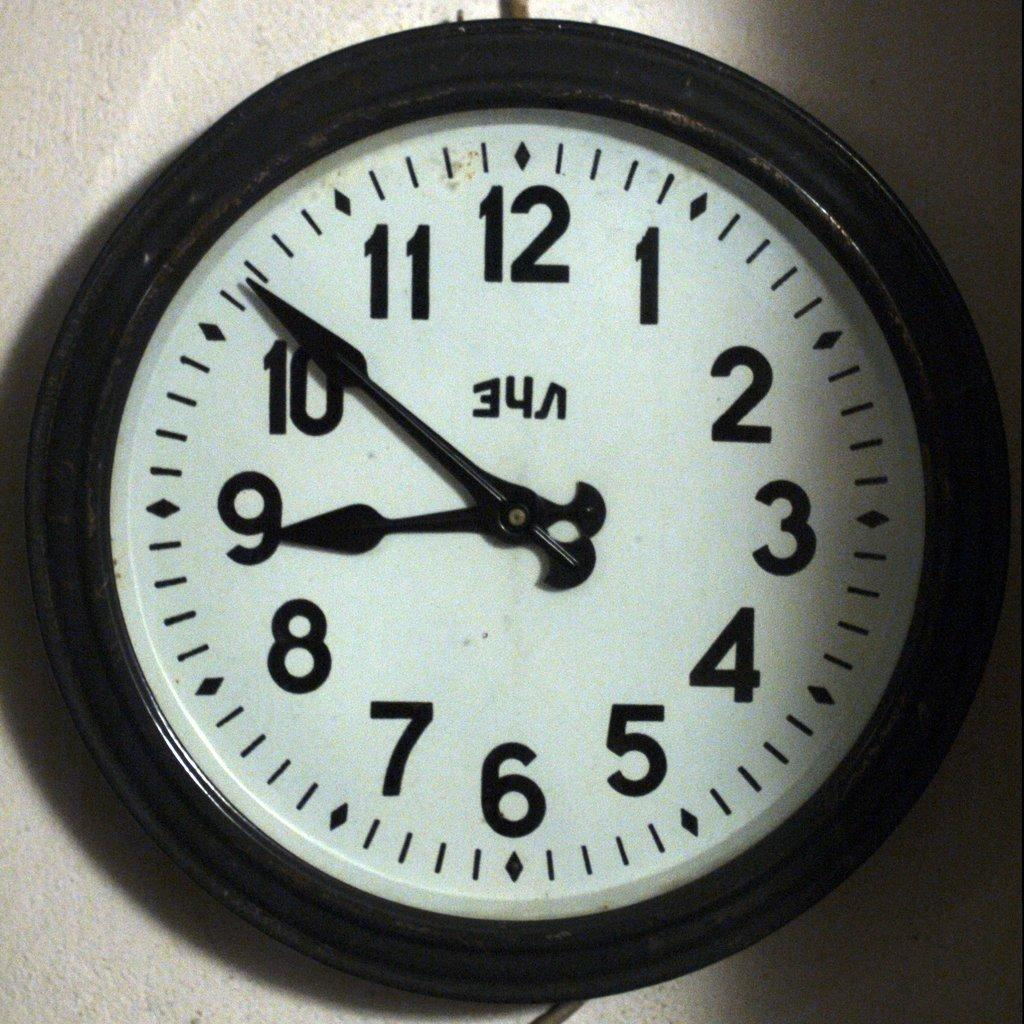<image>
Create a compact narrative representing the image presented. the numbers 1 to 12 that are on a clock 